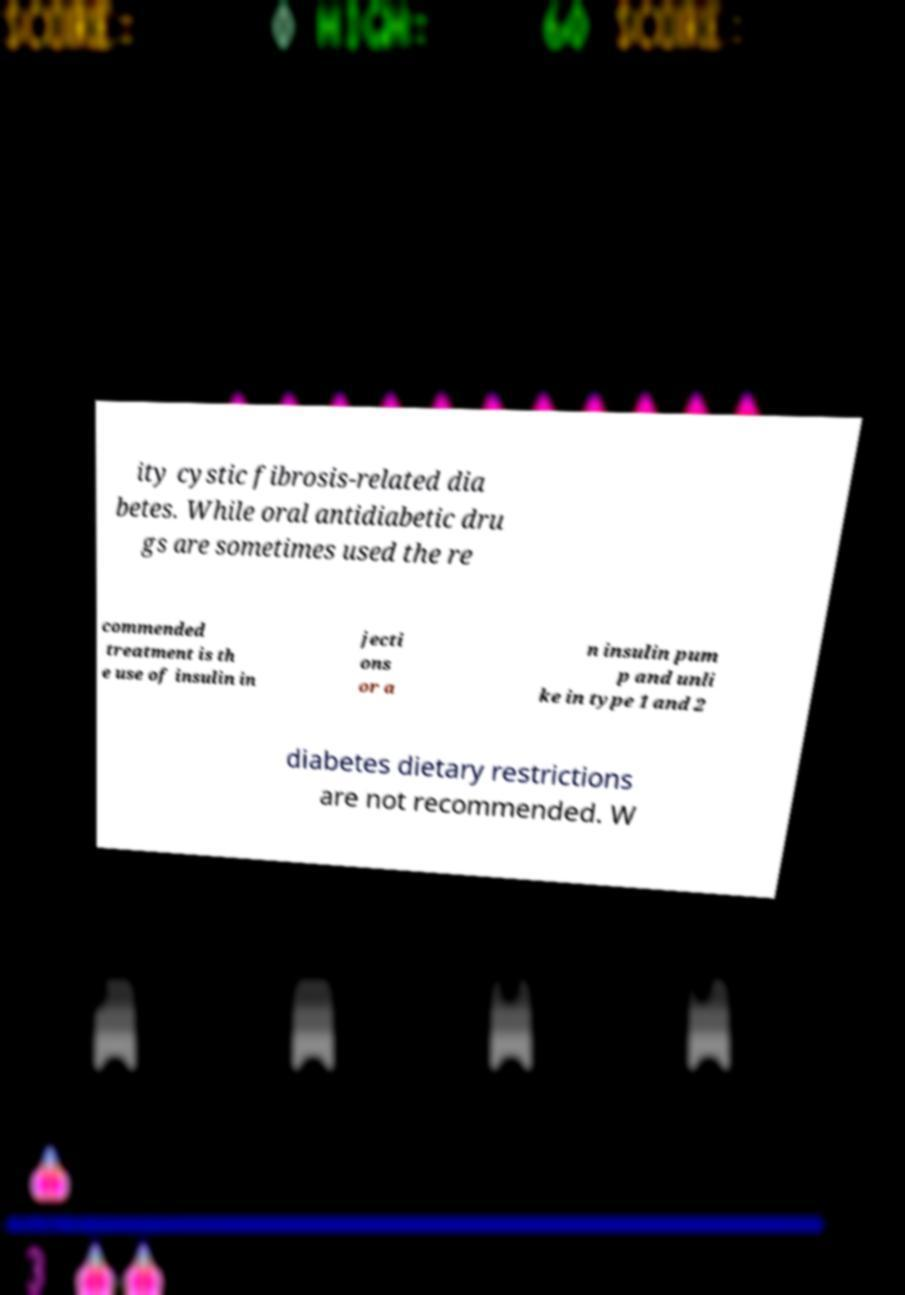Could you extract and type out the text from this image? ity cystic fibrosis-related dia betes. While oral antidiabetic dru gs are sometimes used the re commended treatment is th e use of insulin in jecti ons or a n insulin pum p and unli ke in type 1 and 2 diabetes dietary restrictions are not recommended. W 